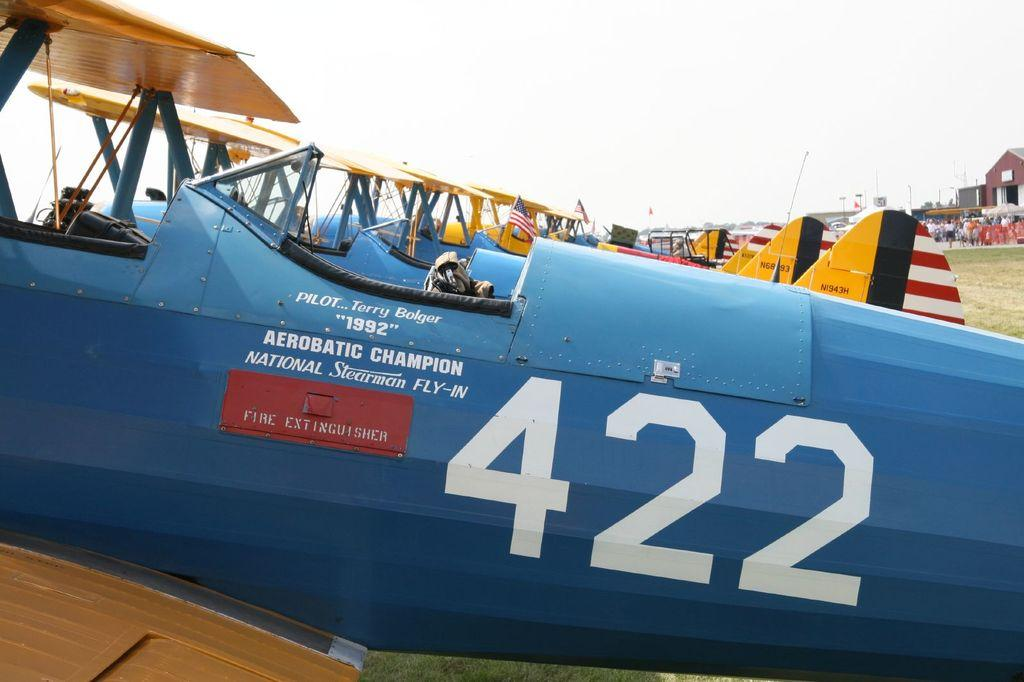<image>
Provide a brief description of the given image. A blue airplane in a lineup that has the number 422 across it 